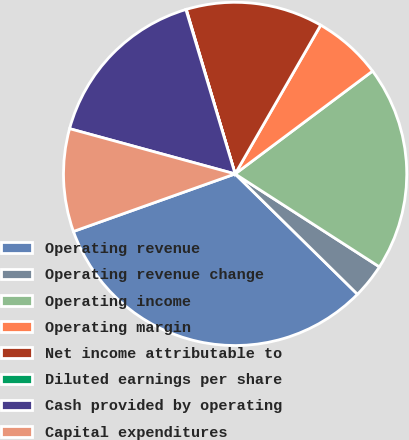Convert chart to OTSL. <chart><loc_0><loc_0><loc_500><loc_500><pie_chart><fcel>Operating revenue<fcel>Operating revenue change<fcel>Operating income<fcel>Operating margin<fcel>Net income attributable to<fcel>Diluted earnings per share<fcel>Cash provided by operating<fcel>Capital expenditures<nl><fcel>32.19%<fcel>3.26%<fcel>19.33%<fcel>6.47%<fcel>12.9%<fcel>0.04%<fcel>16.12%<fcel>9.69%<nl></chart> 